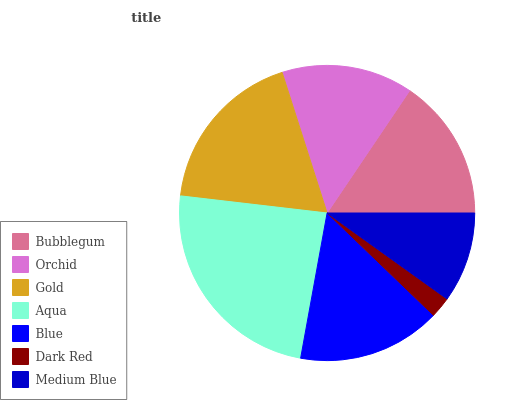Is Dark Red the minimum?
Answer yes or no. Yes. Is Aqua the maximum?
Answer yes or no. Yes. Is Orchid the minimum?
Answer yes or no. No. Is Orchid the maximum?
Answer yes or no. No. Is Bubblegum greater than Orchid?
Answer yes or no. Yes. Is Orchid less than Bubblegum?
Answer yes or no. Yes. Is Orchid greater than Bubblegum?
Answer yes or no. No. Is Bubblegum less than Orchid?
Answer yes or no. No. Is Bubblegum the high median?
Answer yes or no. Yes. Is Bubblegum the low median?
Answer yes or no. Yes. Is Blue the high median?
Answer yes or no. No. Is Gold the low median?
Answer yes or no. No. 